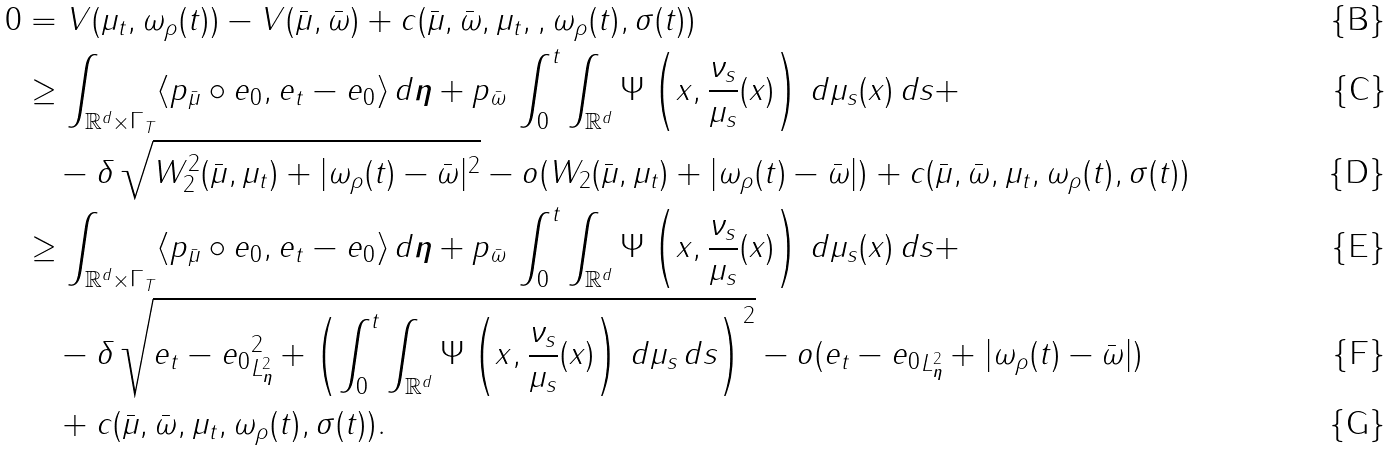Convert formula to latex. <formula><loc_0><loc_0><loc_500><loc_500>0 & = V ( \mu _ { t } , \omega _ { \rho } ( t ) ) - V ( \bar { \mu } , \bar { \omega } ) + c ( \bar { \mu } , \bar { \omega } , \mu _ { t } , , \omega _ { \rho } ( t ) , \sigma ( t ) ) \\ & \geq \int _ { \mathbb { R } ^ { d } \times \Gamma _ { T } } \langle p _ { \bar { \mu } } \circ e _ { 0 } , e _ { t } - e _ { 0 } \rangle \, d \boldsymbol \eta + p _ { \bar { \omega } } \, \int _ { 0 } ^ { t } \int _ { \mathbb { R } ^ { d } } \Psi \left ( x , \frac { \nu _ { s } } { \mu _ { s } } ( x ) \right ) \, d \mu _ { s } ( x ) \, d s + \\ & \quad - \delta \, \sqrt { W _ { 2 } ^ { 2 } ( \bar { \mu } , \mu _ { t } ) + | \omega _ { \rho } ( t ) - \bar { \omega } | ^ { 2 } } - o ( W _ { 2 } ( \bar { \mu } , \mu _ { t } ) + | \omega _ { \rho } ( t ) - \bar { \omega } | ) + c ( \bar { \mu } , \bar { \omega } , \mu _ { t } , \omega _ { \rho } ( t ) , \sigma ( t ) ) \\ & \geq \int _ { \mathbb { R } ^ { d } \times \Gamma _ { T } } \langle p _ { \bar { \mu } } \circ e _ { 0 } , e _ { t } - e _ { 0 } \rangle \, d \boldsymbol \eta + p _ { \bar { \omega } } \, \int _ { 0 } ^ { t } \int _ { \mathbb { R } ^ { d } } \Psi \left ( x , \frac { \nu _ { s } } { \mu _ { s } } ( x ) \right ) \, d \mu _ { s } ( x ) \, d s + \\ & \quad - \delta \, \sqrt { \| e _ { t } - e _ { 0 } \| ^ { 2 } _ { L ^ { 2 } _ { \boldsymbol \eta } } + \left ( \int _ { 0 } ^ { t } \int _ { \mathbb { R } ^ { d } } \Psi \left ( x , \frac { \nu _ { s } } { \mu _ { s } } ( x ) \right ) \, d \mu _ { s } \, d s \right ) ^ { 2 } } - o ( \| e _ { t } - e _ { 0 } \| _ { L ^ { 2 } _ { \boldsymbol \eta } } + | \omega _ { \rho } ( t ) - \bar { \omega } | ) \\ & \quad + c ( \bar { \mu } , \bar { \omega } , \mu _ { t } , \omega _ { \rho } ( t ) , \sigma ( t ) ) .</formula> 